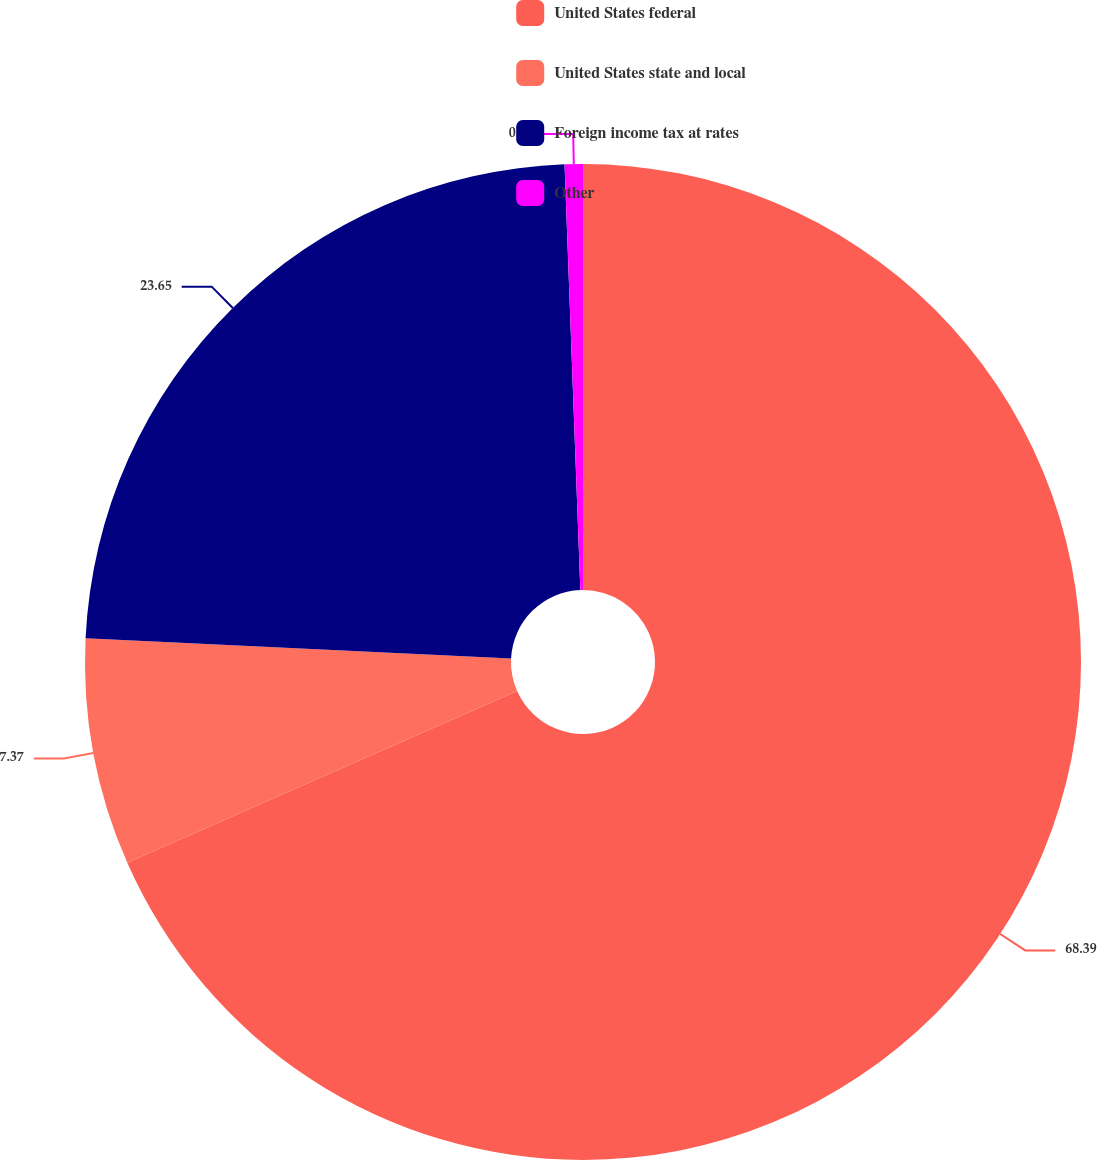Convert chart. <chart><loc_0><loc_0><loc_500><loc_500><pie_chart><fcel>United States federal<fcel>United States state and local<fcel>Foreign income tax at rates<fcel>Other<nl><fcel>68.4%<fcel>7.37%<fcel>23.65%<fcel>0.59%<nl></chart> 